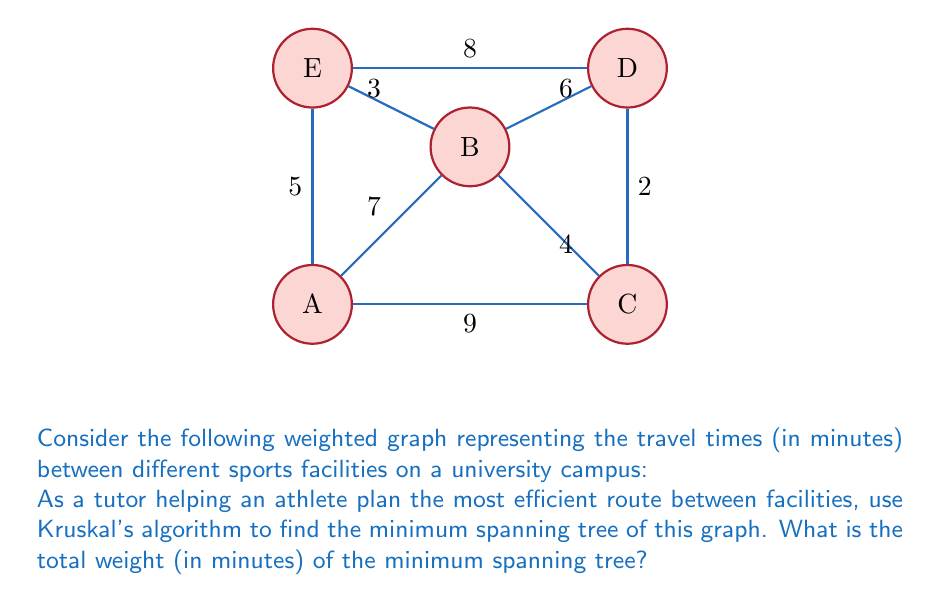What is the answer to this math problem? Let's apply Kruskal's algorithm step by step:

1) First, we list all edges in ascending order of weight:
   (C,D): 2
   (B,E): 3
   (B,C): 4
   (A,E): 5
   (B,D): 6
   (A,B): 7
   (D,E): 8
   (A,C): 9

2) Now, we add edges to our minimum spanning tree (MST) in this order, skipping any that would create a cycle:

   - Add (C,D): 2
   - Add (B,E): 3
   - Add (B,C): 4
   - Add (A,E): 5

3) At this point, we have added 4 edges, which is sufficient for a minimum spanning tree in a graph with 5 vertices (n-1 edges where n is the number of vertices).

4) The total weight of the MST is the sum of the weights of these edges:
   $$2 + 3 + 4 + 5 = 14$$

Therefore, the minimum spanning tree has a total weight of 14 minutes.
Answer: 14 minutes 